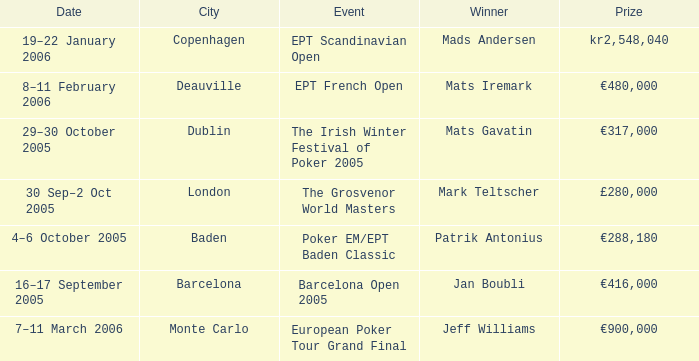What city did an event have a prize of €288,180? Baden. 